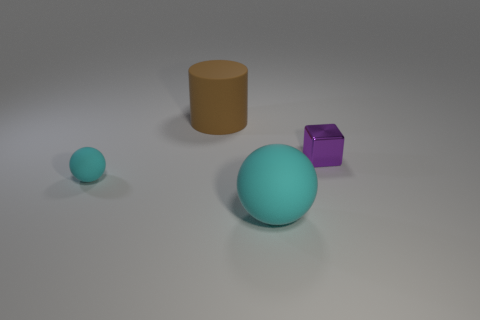Add 4 small cyan metal spheres. How many small cyan metal spheres exist? 4 Add 2 big matte cylinders. How many objects exist? 6 Subtract 0 cyan cylinders. How many objects are left? 4 Subtract 1 balls. How many balls are left? 1 Subtract all cyan cylinders. Subtract all red spheres. How many cylinders are left? 1 Subtract all gray spheres. How many red cubes are left? 0 Subtract all cubes. Subtract all tiny spheres. How many objects are left? 2 Add 1 tiny cyan balls. How many tiny cyan balls are left? 2 